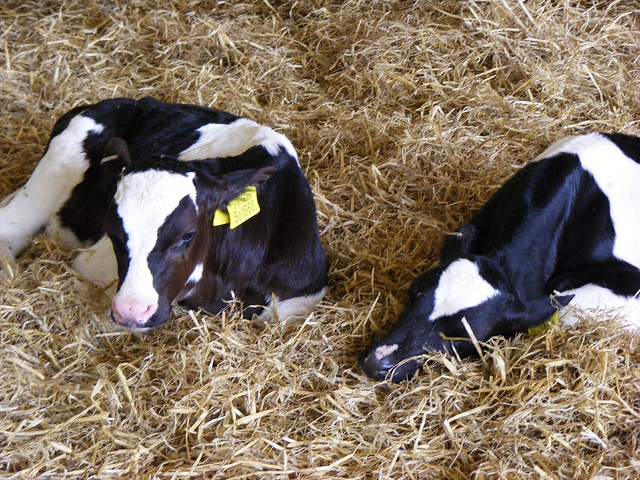Describe the objects in this image and their specific colors. I can see cow in gray, black, lavender, and darkgray tones and cow in gray, black, white, and navy tones in this image. 